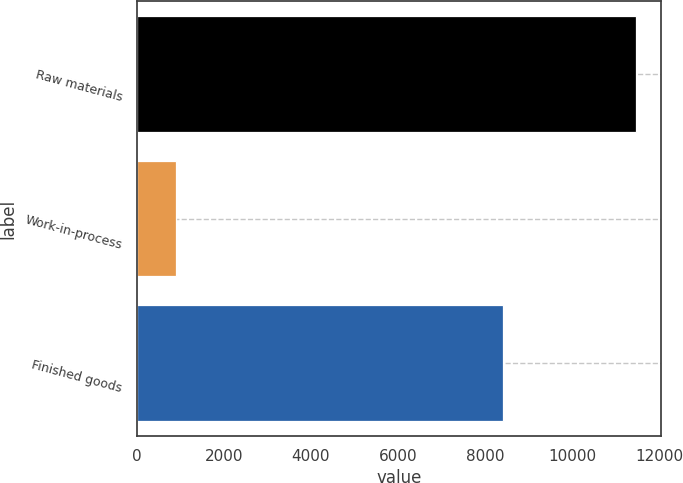Convert chart to OTSL. <chart><loc_0><loc_0><loc_500><loc_500><bar_chart><fcel>Raw materials<fcel>Work-in-process<fcel>Finished goods<nl><fcel>11481<fcel>908<fcel>8413<nl></chart> 